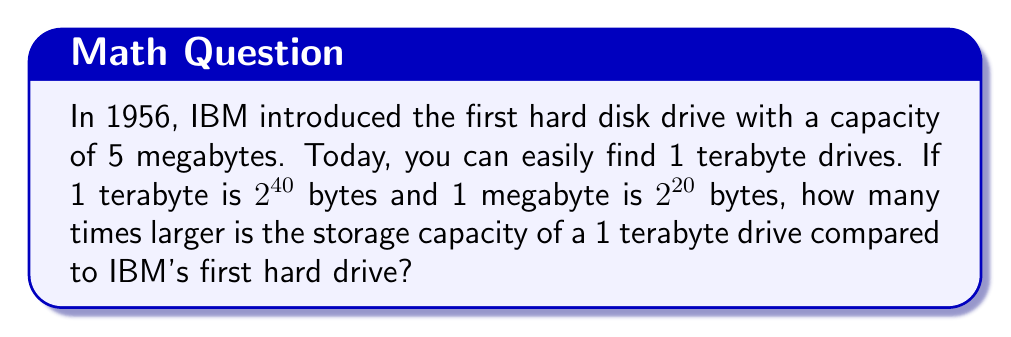Help me with this question. Let's approach this step-by-step:

1) First, let's express both storage capacities in bytes:

   1 TB = $2^{40}$ bytes
   5 MB = $5 \times 2^{20}$ bytes

2) To find how many times larger the 1 TB drive is, we need to divide:

   $\frac{1 \text{ TB}}{5 \text{ MB}} = \frac{2^{40}}{5 \times 2^{20}}$

3) We can simplify this:

   $\frac{2^{40}}{5 \times 2^{20}} = \frac{2^{40}}{5 \times 2^{20}} = \frac{2^{40-20}}{5} = \frac{2^{20}}{5}$

4) Now, let's calculate $2^{20}$:

   $2^{20} = 1,048,576$

5) Finally, we divide by 5:

   $\frac{1,048,576}{5} = 209,715.2$

Therefore, a 1 TB drive is 209,715.2 times larger than IBM's first 5 MB hard drive.
Answer: 209,715.2 times 